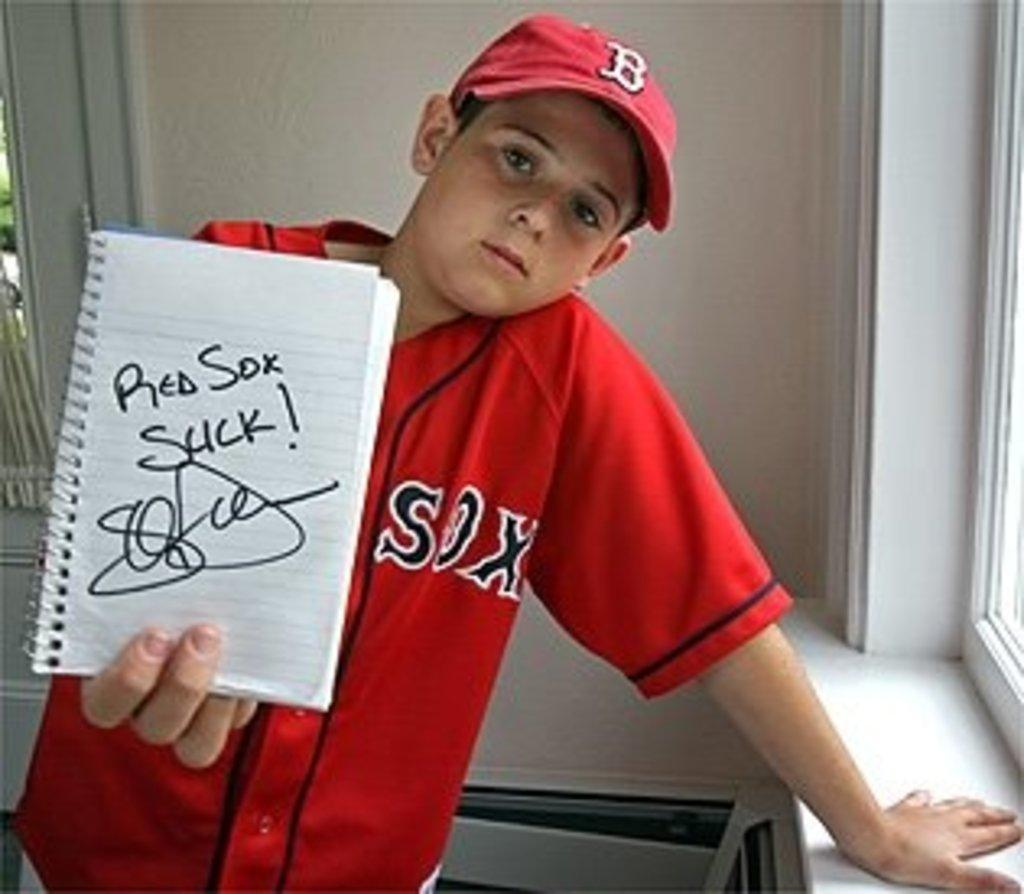Who is the main subject in the image? There is a boy in the image. What is the boy doing in the image? The boy is standing in the image. What is the boy holding in the image? The boy is holding a book in the image. What can be seen in the background of the image? There is a wall and a window in the background of the image. How many windows are visible in the image? There is one window visible on the right side of the image. What type of bird is sitting on the drum in the image? There is no bird or drum present in the image. Who is the stranger standing next to the boy in the image? There is no stranger present in the image; only the boy is visible. 